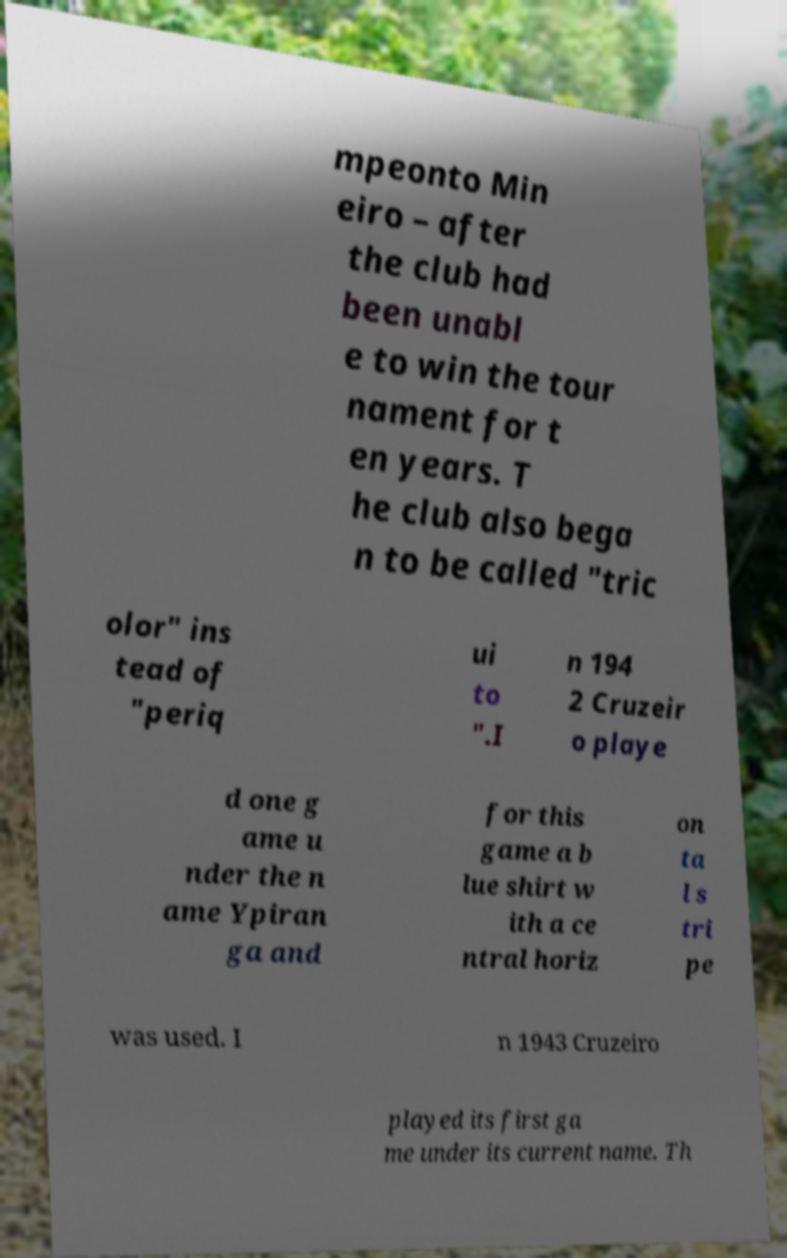I need the written content from this picture converted into text. Can you do that? mpeonto Min eiro – after the club had been unabl e to win the tour nament for t en years. T he club also bega n to be called "tric olor" ins tead of "periq ui to ".I n 194 2 Cruzeir o playe d one g ame u nder the n ame Ypiran ga and for this game a b lue shirt w ith a ce ntral horiz on ta l s tri pe was used. I n 1943 Cruzeiro played its first ga me under its current name. Th 